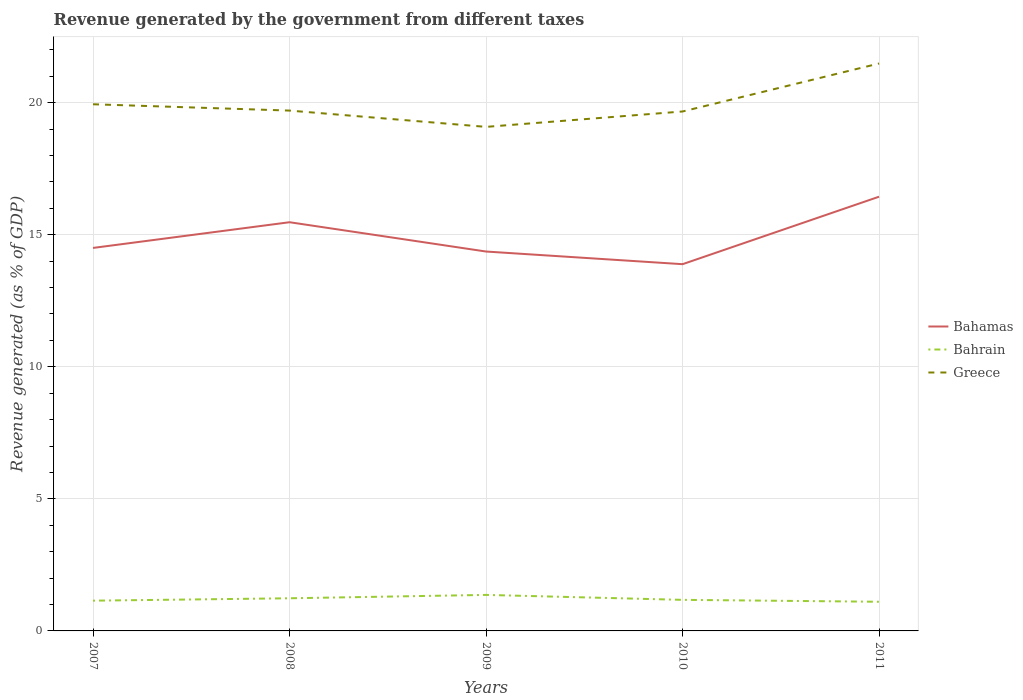How many different coloured lines are there?
Keep it short and to the point. 3. Does the line corresponding to Greece intersect with the line corresponding to Bahrain?
Provide a short and direct response. No. Is the number of lines equal to the number of legend labels?
Your answer should be compact. Yes. Across all years, what is the maximum revenue generated by the government in Bahamas?
Provide a succinct answer. 13.88. In which year was the revenue generated by the government in Bahamas maximum?
Your answer should be compact. 2010. What is the total revenue generated by the government in Bahamas in the graph?
Your response must be concise. 1.11. What is the difference between the highest and the second highest revenue generated by the government in Bahrain?
Your answer should be very brief. 0.26. What is the difference between two consecutive major ticks on the Y-axis?
Offer a very short reply. 5. Does the graph contain grids?
Your answer should be very brief. Yes. Where does the legend appear in the graph?
Your answer should be very brief. Center right. How many legend labels are there?
Make the answer very short. 3. How are the legend labels stacked?
Your answer should be very brief. Vertical. What is the title of the graph?
Your answer should be compact. Revenue generated by the government from different taxes. Does "Georgia" appear as one of the legend labels in the graph?
Provide a short and direct response. No. What is the label or title of the Y-axis?
Your answer should be compact. Revenue generated (as % of GDP). What is the Revenue generated (as % of GDP) in Bahamas in 2007?
Provide a short and direct response. 14.5. What is the Revenue generated (as % of GDP) in Bahrain in 2007?
Offer a very short reply. 1.15. What is the Revenue generated (as % of GDP) in Greece in 2007?
Your answer should be compact. 19.94. What is the Revenue generated (as % of GDP) in Bahamas in 2008?
Provide a succinct answer. 15.47. What is the Revenue generated (as % of GDP) in Bahrain in 2008?
Your response must be concise. 1.24. What is the Revenue generated (as % of GDP) of Greece in 2008?
Offer a terse response. 19.7. What is the Revenue generated (as % of GDP) of Bahamas in 2009?
Keep it short and to the point. 14.36. What is the Revenue generated (as % of GDP) in Bahrain in 2009?
Your answer should be very brief. 1.36. What is the Revenue generated (as % of GDP) of Greece in 2009?
Offer a terse response. 19.08. What is the Revenue generated (as % of GDP) of Bahamas in 2010?
Provide a short and direct response. 13.88. What is the Revenue generated (as % of GDP) of Bahrain in 2010?
Keep it short and to the point. 1.18. What is the Revenue generated (as % of GDP) in Greece in 2010?
Your response must be concise. 19.66. What is the Revenue generated (as % of GDP) in Bahamas in 2011?
Keep it short and to the point. 16.44. What is the Revenue generated (as % of GDP) in Bahrain in 2011?
Your answer should be compact. 1.1. What is the Revenue generated (as % of GDP) in Greece in 2011?
Keep it short and to the point. 21.48. Across all years, what is the maximum Revenue generated (as % of GDP) of Bahamas?
Your answer should be very brief. 16.44. Across all years, what is the maximum Revenue generated (as % of GDP) of Bahrain?
Provide a succinct answer. 1.36. Across all years, what is the maximum Revenue generated (as % of GDP) in Greece?
Your answer should be compact. 21.48. Across all years, what is the minimum Revenue generated (as % of GDP) in Bahamas?
Offer a terse response. 13.88. Across all years, what is the minimum Revenue generated (as % of GDP) in Bahrain?
Keep it short and to the point. 1.1. Across all years, what is the minimum Revenue generated (as % of GDP) of Greece?
Provide a succinct answer. 19.08. What is the total Revenue generated (as % of GDP) in Bahamas in the graph?
Your response must be concise. 74.65. What is the total Revenue generated (as % of GDP) in Bahrain in the graph?
Offer a very short reply. 6.02. What is the total Revenue generated (as % of GDP) in Greece in the graph?
Your response must be concise. 99.86. What is the difference between the Revenue generated (as % of GDP) in Bahamas in 2007 and that in 2008?
Ensure brevity in your answer.  -0.97. What is the difference between the Revenue generated (as % of GDP) in Bahrain in 2007 and that in 2008?
Your answer should be compact. -0.09. What is the difference between the Revenue generated (as % of GDP) in Greece in 2007 and that in 2008?
Offer a very short reply. 0.24. What is the difference between the Revenue generated (as % of GDP) of Bahamas in 2007 and that in 2009?
Provide a succinct answer. 0.14. What is the difference between the Revenue generated (as % of GDP) in Bahrain in 2007 and that in 2009?
Provide a succinct answer. -0.22. What is the difference between the Revenue generated (as % of GDP) of Greece in 2007 and that in 2009?
Ensure brevity in your answer.  0.86. What is the difference between the Revenue generated (as % of GDP) of Bahamas in 2007 and that in 2010?
Your answer should be compact. 0.62. What is the difference between the Revenue generated (as % of GDP) in Bahrain in 2007 and that in 2010?
Provide a short and direct response. -0.03. What is the difference between the Revenue generated (as % of GDP) of Greece in 2007 and that in 2010?
Keep it short and to the point. 0.27. What is the difference between the Revenue generated (as % of GDP) of Bahamas in 2007 and that in 2011?
Provide a short and direct response. -1.94. What is the difference between the Revenue generated (as % of GDP) in Bahrain in 2007 and that in 2011?
Give a very brief answer. 0.04. What is the difference between the Revenue generated (as % of GDP) in Greece in 2007 and that in 2011?
Your answer should be very brief. -1.54. What is the difference between the Revenue generated (as % of GDP) in Bahamas in 2008 and that in 2009?
Give a very brief answer. 1.11. What is the difference between the Revenue generated (as % of GDP) of Bahrain in 2008 and that in 2009?
Provide a succinct answer. -0.13. What is the difference between the Revenue generated (as % of GDP) in Greece in 2008 and that in 2009?
Keep it short and to the point. 0.62. What is the difference between the Revenue generated (as % of GDP) in Bahamas in 2008 and that in 2010?
Your response must be concise. 1.59. What is the difference between the Revenue generated (as % of GDP) in Bahrain in 2008 and that in 2010?
Your answer should be very brief. 0.06. What is the difference between the Revenue generated (as % of GDP) in Greece in 2008 and that in 2010?
Offer a very short reply. 0.03. What is the difference between the Revenue generated (as % of GDP) of Bahamas in 2008 and that in 2011?
Provide a succinct answer. -0.97. What is the difference between the Revenue generated (as % of GDP) of Bahrain in 2008 and that in 2011?
Your answer should be very brief. 0.13. What is the difference between the Revenue generated (as % of GDP) of Greece in 2008 and that in 2011?
Ensure brevity in your answer.  -1.78. What is the difference between the Revenue generated (as % of GDP) of Bahamas in 2009 and that in 2010?
Keep it short and to the point. 0.48. What is the difference between the Revenue generated (as % of GDP) in Bahrain in 2009 and that in 2010?
Make the answer very short. 0.19. What is the difference between the Revenue generated (as % of GDP) in Greece in 2009 and that in 2010?
Provide a succinct answer. -0.58. What is the difference between the Revenue generated (as % of GDP) in Bahamas in 2009 and that in 2011?
Make the answer very short. -2.08. What is the difference between the Revenue generated (as % of GDP) of Bahrain in 2009 and that in 2011?
Keep it short and to the point. 0.26. What is the difference between the Revenue generated (as % of GDP) of Greece in 2009 and that in 2011?
Make the answer very short. -2.4. What is the difference between the Revenue generated (as % of GDP) in Bahamas in 2010 and that in 2011?
Offer a very short reply. -2.55. What is the difference between the Revenue generated (as % of GDP) in Bahrain in 2010 and that in 2011?
Your answer should be very brief. 0.07. What is the difference between the Revenue generated (as % of GDP) of Greece in 2010 and that in 2011?
Offer a terse response. -1.82. What is the difference between the Revenue generated (as % of GDP) in Bahamas in 2007 and the Revenue generated (as % of GDP) in Bahrain in 2008?
Give a very brief answer. 13.26. What is the difference between the Revenue generated (as % of GDP) of Bahamas in 2007 and the Revenue generated (as % of GDP) of Greece in 2008?
Make the answer very short. -5.2. What is the difference between the Revenue generated (as % of GDP) in Bahrain in 2007 and the Revenue generated (as % of GDP) in Greece in 2008?
Make the answer very short. -18.55. What is the difference between the Revenue generated (as % of GDP) in Bahamas in 2007 and the Revenue generated (as % of GDP) in Bahrain in 2009?
Provide a succinct answer. 13.14. What is the difference between the Revenue generated (as % of GDP) in Bahamas in 2007 and the Revenue generated (as % of GDP) in Greece in 2009?
Offer a terse response. -4.58. What is the difference between the Revenue generated (as % of GDP) in Bahrain in 2007 and the Revenue generated (as % of GDP) in Greece in 2009?
Give a very brief answer. -17.94. What is the difference between the Revenue generated (as % of GDP) of Bahamas in 2007 and the Revenue generated (as % of GDP) of Bahrain in 2010?
Offer a very short reply. 13.32. What is the difference between the Revenue generated (as % of GDP) in Bahamas in 2007 and the Revenue generated (as % of GDP) in Greece in 2010?
Your answer should be very brief. -5.17. What is the difference between the Revenue generated (as % of GDP) of Bahrain in 2007 and the Revenue generated (as % of GDP) of Greece in 2010?
Make the answer very short. -18.52. What is the difference between the Revenue generated (as % of GDP) of Bahamas in 2007 and the Revenue generated (as % of GDP) of Bahrain in 2011?
Your response must be concise. 13.39. What is the difference between the Revenue generated (as % of GDP) of Bahamas in 2007 and the Revenue generated (as % of GDP) of Greece in 2011?
Your answer should be very brief. -6.98. What is the difference between the Revenue generated (as % of GDP) of Bahrain in 2007 and the Revenue generated (as % of GDP) of Greece in 2011?
Make the answer very short. -20.34. What is the difference between the Revenue generated (as % of GDP) of Bahamas in 2008 and the Revenue generated (as % of GDP) of Bahrain in 2009?
Make the answer very short. 14.11. What is the difference between the Revenue generated (as % of GDP) of Bahamas in 2008 and the Revenue generated (as % of GDP) of Greece in 2009?
Your response must be concise. -3.61. What is the difference between the Revenue generated (as % of GDP) in Bahrain in 2008 and the Revenue generated (as % of GDP) in Greece in 2009?
Provide a short and direct response. -17.85. What is the difference between the Revenue generated (as % of GDP) in Bahamas in 2008 and the Revenue generated (as % of GDP) in Bahrain in 2010?
Offer a very short reply. 14.3. What is the difference between the Revenue generated (as % of GDP) in Bahamas in 2008 and the Revenue generated (as % of GDP) in Greece in 2010?
Keep it short and to the point. -4.19. What is the difference between the Revenue generated (as % of GDP) in Bahrain in 2008 and the Revenue generated (as % of GDP) in Greece in 2010?
Provide a short and direct response. -18.43. What is the difference between the Revenue generated (as % of GDP) of Bahamas in 2008 and the Revenue generated (as % of GDP) of Bahrain in 2011?
Keep it short and to the point. 14.37. What is the difference between the Revenue generated (as % of GDP) of Bahamas in 2008 and the Revenue generated (as % of GDP) of Greece in 2011?
Offer a terse response. -6.01. What is the difference between the Revenue generated (as % of GDP) in Bahrain in 2008 and the Revenue generated (as % of GDP) in Greece in 2011?
Keep it short and to the point. -20.24. What is the difference between the Revenue generated (as % of GDP) of Bahamas in 2009 and the Revenue generated (as % of GDP) of Bahrain in 2010?
Give a very brief answer. 13.19. What is the difference between the Revenue generated (as % of GDP) in Bahamas in 2009 and the Revenue generated (as % of GDP) in Greece in 2010?
Your answer should be compact. -5.3. What is the difference between the Revenue generated (as % of GDP) in Bahrain in 2009 and the Revenue generated (as % of GDP) in Greece in 2010?
Provide a short and direct response. -18.3. What is the difference between the Revenue generated (as % of GDP) of Bahamas in 2009 and the Revenue generated (as % of GDP) of Bahrain in 2011?
Make the answer very short. 13.26. What is the difference between the Revenue generated (as % of GDP) in Bahamas in 2009 and the Revenue generated (as % of GDP) in Greece in 2011?
Provide a succinct answer. -7.12. What is the difference between the Revenue generated (as % of GDP) in Bahrain in 2009 and the Revenue generated (as % of GDP) in Greece in 2011?
Give a very brief answer. -20.12. What is the difference between the Revenue generated (as % of GDP) in Bahamas in 2010 and the Revenue generated (as % of GDP) in Bahrain in 2011?
Provide a short and direct response. 12.78. What is the difference between the Revenue generated (as % of GDP) of Bahamas in 2010 and the Revenue generated (as % of GDP) of Greece in 2011?
Make the answer very short. -7.6. What is the difference between the Revenue generated (as % of GDP) in Bahrain in 2010 and the Revenue generated (as % of GDP) in Greece in 2011?
Keep it short and to the point. -20.3. What is the average Revenue generated (as % of GDP) of Bahamas per year?
Keep it short and to the point. 14.93. What is the average Revenue generated (as % of GDP) of Bahrain per year?
Give a very brief answer. 1.2. What is the average Revenue generated (as % of GDP) of Greece per year?
Your answer should be very brief. 19.97. In the year 2007, what is the difference between the Revenue generated (as % of GDP) in Bahamas and Revenue generated (as % of GDP) in Bahrain?
Provide a short and direct response. 13.35. In the year 2007, what is the difference between the Revenue generated (as % of GDP) of Bahamas and Revenue generated (as % of GDP) of Greece?
Your answer should be compact. -5.44. In the year 2007, what is the difference between the Revenue generated (as % of GDP) in Bahrain and Revenue generated (as % of GDP) in Greece?
Ensure brevity in your answer.  -18.79. In the year 2008, what is the difference between the Revenue generated (as % of GDP) in Bahamas and Revenue generated (as % of GDP) in Bahrain?
Keep it short and to the point. 14.24. In the year 2008, what is the difference between the Revenue generated (as % of GDP) in Bahamas and Revenue generated (as % of GDP) in Greece?
Your answer should be compact. -4.23. In the year 2008, what is the difference between the Revenue generated (as % of GDP) of Bahrain and Revenue generated (as % of GDP) of Greece?
Ensure brevity in your answer.  -18.46. In the year 2009, what is the difference between the Revenue generated (as % of GDP) in Bahamas and Revenue generated (as % of GDP) in Bahrain?
Keep it short and to the point. 13. In the year 2009, what is the difference between the Revenue generated (as % of GDP) of Bahamas and Revenue generated (as % of GDP) of Greece?
Provide a succinct answer. -4.72. In the year 2009, what is the difference between the Revenue generated (as % of GDP) of Bahrain and Revenue generated (as % of GDP) of Greece?
Your answer should be very brief. -17.72. In the year 2010, what is the difference between the Revenue generated (as % of GDP) of Bahamas and Revenue generated (as % of GDP) of Bahrain?
Offer a very short reply. 12.71. In the year 2010, what is the difference between the Revenue generated (as % of GDP) of Bahamas and Revenue generated (as % of GDP) of Greece?
Give a very brief answer. -5.78. In the year 2010, what is the difference between the Revenue generated (as % of GDP) of Bahrain and Revenue generated (as % of GDP) of Greece?
Make the answer very short. -18.49. In the year 2011, what is the difference between the Revenue generated (as % of GDP) of Bahamas and Revenue generated (as % of GDP) of Bahrain?
Provide a succinct answer. 15.33. In the year 2011, what is the difference between the Revenue generated (as % of GDP) in Bahamas and Revenue generated (as % of GDP) in Greece?
Offer a very short reply. -5.04. In the year 2011, what is the difference between the Revenue generated (as % of GDP) of Bahrain and Revenue generated (as % of GDP) of Greece?
Make the answer very short. -20.38. What is the ratio of the Revenue generated (as % of GDP) in Bahamas in 2007 to that in 2008?
Provide a succinct answer. 0.94. What is the ratio of the Revenue generated (as % of GDP) of Bahrain in 2007 to that in 2008?
Your response must be concise. 0.93. What is the ratio of the Revenue generated (as % of GDP) in Greece in 2007 to that in 2008?
Give a very brief answer. 1.01. What is the ratio of the Revenue generated (as % of GDP) in Bahamas in 2007 to that in 2009?
Make the answer very short. 1.01. What is the ratio of the Revenue generated (as % of GDP) of Bahrain in 2007 to that in 2009?
Ensure brevity in your answer.  0.84. What is the ratio of the Revenue generated (as % of GDP) in Greece in 2007 to that in 2009?
Keep it short and to the point. 1.04. What is the ratio of the Revenue generated (as % of GDP) in Bahamas in 2007 to that in 2010?
Give a very brief answer. 1.04. What is the ratio of the Revenue generated (as % of GDP) in Bahrain in 2007 to that in 2010?
Keep it short and to the point. 0.97. What is the ratio of the Revenue generated (as % of GDP) in Greece in 2007 to that in 2010?
Your answer should be very brief. 1.01. What is the ratio of the Revenue generated (as % of GDP) in Bahamas in 2007 to that in 2011?
Provide a short and direct response. 0.88. What is the ratio of the Revenue generated (as % of GDP) in Bahrain in 2007 to that in 2011?
Ensure brevity in your answer.  1.04. What is the ratio of the Revenue generated (as % of GDP) of Greece in 2007 to that in 2011?
Your response must be concise. 0.93. What is the ratio of the Revenue generated (as % of GDP) in Bahamas in 2008 to that in 2009?
Your answer should be very brief. 1.08. What is the ratio of the Revenue generated (as % of GDP) of Bahrain in 2008 to that in 2009?
Provide a succinct answer. 0.91. What is the ratio of the Revenue generated (as % of GDP) of Greece in 2008 to that in 2009?
Provide a succinct answer. 1.03. What is the ratio of the Revenue generated (as % of GDP) in Bahamas in 2008 to that in 2010?
Your answer should be very brief. 1.11. What is the ratio of the Revenue generated (as % of GDP) in Bahrain in 2008 to that in 2010?
Offer a very short reply. 1.05. What is the ratio of the Revenue generated (as % of GDP) of Greece in 2008 to that in 2010?
Make the answer very short. 1. What is the ratio of the Revenue generated (as % of GDP) in Bahamas in 2008 to that in 2011?
Your response must be concise. 0.94. What is the ratio of the Revenue generated (as % of GDP) of Bahrain in 2008 to that in 2011?
Ensure brevity in your answer.  1.12. What is the ratio of the Revenue generated (as % of GDP) in Greece in 2008 to that in 2011?
Your answer should be very brief. 0.92. What is the ratio of the Revenue generated (as % of GDP) in Bahamas in 2009 to that in 2010?
Your answer should be very brief. 1.03. What is the ratio of the Revenue generated (as % of GDP) of Bahrain in 2009 to that in 2010?
Ensure brevity in your answer.  1.16. What is the ratio of the Revenue generated (as % of GDP) in Greece in 2009 to that in 2010?
Your response must be concise. 0.97. What is the ratio of the Revenue generated (as % of GDP) in Bahamas in 2009 to that in 2011?
Provide a succinct answer. 0.87. What is the ratio of the Revenue generated (as % of GDP) in Bahrain in 2009 to that in 2011?
Your answer should be compact. 1.23. What is the ratio of the Revenue generated (as % of GDP) of Greece in 2009 to that in 2011?
Your response must be concise. 0.89. What is the ratio of the Revenue generated (as % of GDP) of Bahamas in 2010 to that in 2011?
Provide a short and direct response. 0.84. What is the ratio of the Revenue generated (as % of GDP) in Bahrain in 2010 to that in 2011?
Keep it short and to the point. 1.07. What is the ratio of the Revenue generated (as % of GDP) in Greece in 2010 to that in 2011?
Ensure brevity in your answer.  0.92. What is the difference between the highest and the second highest Revenue generated (as % of GDP) of Bahamas?
Your answer should be very brief. 0.97. What is the difference between the highest and the second highest Revenue generated (as % of GDP) of Bahrain?
Your answer should be compact. 0.13. What is the difference between the highest and the second highest Revenue generated (as % of GDP) in Greece?
Provide a short and direct response. 1.54. What is the difference between the highest and the lowest Revenue generated (as % of GDP) of Bahamas?
Offer a terse response. 2.55. What is the difference between the highest and the lowest Revenue generated (as % of GDP) in Bahrain?
Keep it short and to the point. 0.26. What is the difference between the highest and the lowest Revenue generated (as % of GDP) in Greece?
Your answer should be very brief. 2.4. 